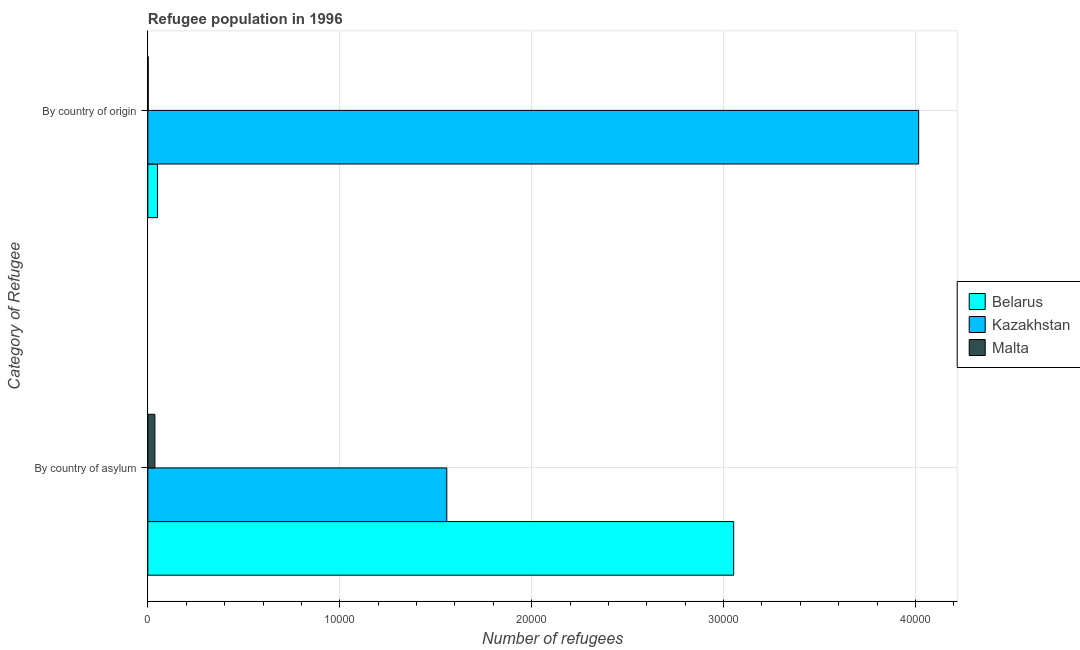How many groups of bars are there?
Your answer should be very brief. 2. How many bars are there on the 2nd tick from the bottom?
Provide a succinct answer. 3. What is the label of the 2nd group of bars from the top?
Offer a terse response. By country of asylum. What is the number of refugees by country of origin in Kazakhstan?
Offer a terse response. 4.02e+04. Across all countries, what is the maximum number of refugees by country of origin?
Your response must be concise. 4.02e+04. Across all countries, what is the minimum number of refugees by country of asylum?
Offer a very short reply. 367. In which country was the number of refugees by country of origin maximum?
Offer a terse response. Kazakhstan. In which country was the number of refugees by country of asylum minimum?
Give a very brief answer. Malta. What is the total number of refugees by country of origin in the graph?
Your answer should be very brief. 4.07e+04. What is the difference between the number of refugees by country of asylum in Belarus and that in Malta?
Provide a short and direct response. 3.02e+04. What is the difference between the number of refugees by country of asylum in Kazakhstan and the number of refugees by country of origin in Malta?
Give a very brief answer. 1.56e+04. What is the average number of refugees by country of asylum per country?
Make the answer very short. 1.55e+04. What is the difference between the number of refugees by country of origin and number of refugees by country of asylum in Belarus?
Give a very brief answer. -3.00e+04. What is the ratio of the number of refugees by country of asylum in Kazakhstan to that in Belarus?
Your answer should be compact. 0.51. Is the number of refugees by country of asylum in Kazakhstan less than that in Malta?
Provide a succinct answer. No. What does the 2nd bar from the top in By country of asylum represents?
Offer a terse response. Kazakhstan. What does the 1st bar from the bottom in By country of origin represents?
Keep it short and to the point. Belarus. How many countries are there in the graph?
Your answer should be compact. 3. Are the values on the major ticks of X-axis written in scientific E-notation?
Offer a very short reply. No. Does the graph contain any zero values?
Keep it short and to the point. No. What is the title of the graph?
Your response must be concise. Refugee population in 1996. What is the label or title of the X-axis?
Your response must be concise. Number of refugees. What is the label or title of the Y-axis?
Offer a very short reply. Category of Refugee. What is the Number of refugees of Belarus in By country of asylum?
Your answer should be compact. 3.05e+04. What is the Number of refugees in Kazakhstan in By country of asylum?
Provide a short and direct response. 1.56e+04. What is the Number of refugees of Malta in By country of asylum?
Your response must be concise. 367. What is the Number of refugees in Belarus in By country of origin?
Make the answer very short. 501. What is the Number of refugees of Kazakhstan in By country of origin?
Keep it short and to the point. 4.02e+04. What is the Number of refugees in Malta in By country of origin?
Your response must be concise. 18. Across all Category of Refugee, what is the maximum Number of refugees in Belarus?
Offer a very short reply. 3.05e+04. Across all Category of Refugee, what is the maximum Number of refugees of Kazakhstan?
Your answer should be compact. 4.02e+04. Across all Category of Refugee, what is the maximum Number of refugees in Malta?
Provide a short and direct response. 367. Across all Category of Refugee, what is the minimum Number of refugees of Belarus?
Keep it short and to the point. 501. Across all Category of Refugee, what is the minimum Number of refugees of Kazakhstan?
Offer a very short reply. 1.56e+04. Across all Category of Refugee, what is the minimum Number of refugees of Malta?
Make the answer very short. 18. What is the total Number of refugees of Belarus in the graph?
Provide a short and direct response. 3.10e+04. What is the total Number of refugees in Kazakhstan in the graph?
Make the answer very short. 5.57e+04. What is the total Number of refugees in Malta in the graph?
Your response must be concise. 385. What is the difference between the Number of refugees in Belarus in By country of asylum and that in By country of origin?
Your answer should be compact. 3.00e+04. What is the difference between the Number of refugees in Kazakhstan in By country of asylum and that in By country of origin?
Give a very brief answer. -2.46e+04. What is the difference between the Number of refugees in Malta in By country of asylum and that in By country of origin?
Your response must be concise. 349. What is the difference between the Number of refugees of Belarus in By country of asylum and the Number of refugees of Kazakhstan in By country of origin?
Provide a short and direct response. -9638. What is the difference between the Number of refugees of Belarus in By country of asylum and the Number of refugees of Malta in By country of origin?
Provide a succinct answer. 3.05e+04. What is the difference between the Number of refugees of Kazakhstan in By country of asylum and the Number of refugees of Malta in By country of origin?
Provide a succinct answer. 1.56e+04. What is the average Number of refugees of Belarus per Category of Refugee?
Keep it short and to the point. 1.55e+04. What is the average Number of refugees of Kazakhstan per Category of Refugee?
Make the answer very short. 2.79e+04. What is the average Number of refugees of Malta per Category of Refugee?
Provide a short and direct response. 192.5. What is the difference between the Number of refugees in Belarus and Number of refugees in Kazakhstan in By country of asylum?
Your response must be concise. 1.49e+04. What is the difference between the Number of refugees in Belarus and Number of refugees in Malta in By country of asylum?
Provide a succinct answer. 3.02e+04. What is the difference between the Number of refugees of Kazakhstan and Number of refugees of Malta in By country of asylum?
Provide a succinct answer. 1.52e+04. What is the difference between the Number of refugees of Belarus and Number of refugees of Kazakhstan in By country of origin?
Ensure brevity in your answer.  -3.97e+04. What is the difference between the Number of refugees in Belarus and Number of refugees in Malta in By country of origin?
Your answer should be compact. 483. What is the difference between the Number of refugees in Kazakhstan and Number of refugees in Malta in By country of origin?
Provide a succinct answer. 4.01e+04. What is the ratio of the Number of refugees of Belarus in By country of asylum to that in By country of origin?
Ensure brevity in your answer.  60.93. What is the ratio of the Number of refugees of Kazakhstan in By country of asylum to that in By country of origin?
Give a very brief answer. 0.39. What is the ratio of the Number of refugees in Malta in By country of asylum to that in By country of origin?
Your answer should be very brief. 20.39. What is the difference between the highest and the second highest Number of refugees in Belarus?
Ensure brevity in your answer.  3.00e+04. What is the difference between the highest and the second highest Number of refugees in Kazakhstan?
Your answer should be compact. 2.46e+04. What is the difference between the highest and the second highest Number of refugees in Malta?
Make the answer very short. 349. What is the difference between the highest and the lowest Number of refugees of Belarus?
Offer a very short reply. 3.00e+04. What is the difference between the highest and the lowest Number of refugees of Kazakhstan?
Make the answer very short. 2.46e+04. What is the difference between the highest and the lowest Number of refugees in Malta?
Offer a terse response. 349. 